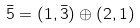<formula> <loc_0><loc_0><loc_500><loc_500>\bar { 5 } = ( 1 , \bar { 3 } ) \oplus ( 2 , 1 )</formula> 